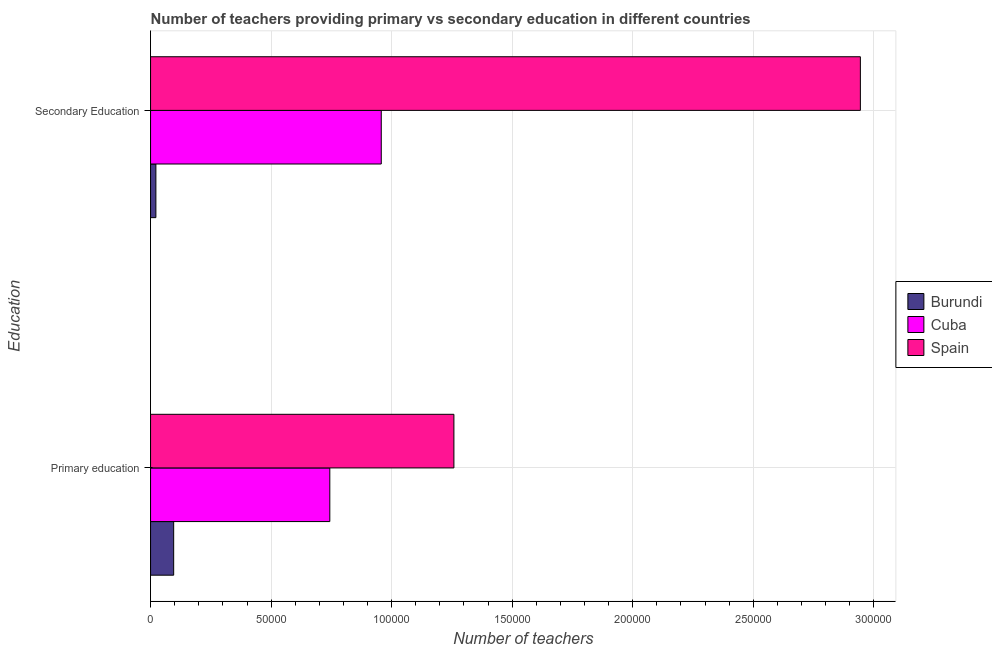How many groups of bars are there?
Provide a short and direct response. 2. Are the number of bars per tick equal to the number of legend labels?
Your answer should be compact. Yes. Are the number of bars on each tick of the Y-axis equal?
Your response must be concise. Yes. How many bars are there on the 2nd tick from the top?
Your answer should be compact. 3. What is the number of secondary teachers in Spain?
Offer a very short reply. 2.94e+05. Across all countries, what is the maximum number of primary teachers?
Your answer should be compact. 1.26e+05. Across all countries, what is the minimum number of secondary teachers?
Give a very brief answer. 2211. In which country was the number of primary teachers maximum?
Provide a short and direct response. Spain. In which country was the number of secondary teachers minimum?
Make the answer very short. Burundi. What is the total number of primary teachers in the graph?
Provide a short and direct response. 2.10e+05. What is the difference between the number of primary teachers in Cuba and that in Spain?
Provide a short and direct response. -5.15e+04. What is the difference between the number of secondary teachers in Burundi and the number of primary teachers in Spain?
Offer a very short reply. -1.24e+05. What is the average number of secondary teachers per country?
Make the answer very short. 1.31e+05. What is the difference between the number of primary teachers and number of secondary teachers in Cuba?
Offer a very short reply. -2.13e+04. In how many countries, is the number of secondary teachers greater than 270000 ?
Provide a short and direct response. 1. What is the ratio of the number of primary teachers in Cuba to that in Burundi?
Ensure brevity in your answer.  7.76. Is the number of primary teachers in Spain less than that in Burundi?
Provide a short and direct response. No. What does the 2nd bar from the top in Secondary Education represents?
Give a very brief answer. Cuba. Are the values on the major ticks of X-axis written in scientific E-notation?
Your answer should be very brief. No. Does the graph contain any zero values?
Your answer should be very brief. No. Where does the legend appear in the graph?
Make the answer very short. Center right. How many legend labels are there?
Provide a succinct answer. 3. How are the legend labels stacked?
Your response must be concise. Vertical. What is the title of the graph?
Offer a very short reply. Number of teachers providing primary vs secondary education in different countries. Does "Oman" appear as one of the legend labels in the graph?
Provide a short and direct response. No. What is the label or title of the X-axis?
Offer a terse response. Number of teachers. What is the label or title of the Y-axis?
Your answer should be compact. Education. What is the Number of teachers of Burundi in Primary education?
Offer a very short reply. 9582. What is the Number of teachers in Cuba in Primary education?
Provide a short and direct response. 7.44e+04. What is the Number of teachers of Spain in Primary education?
Offer a terse response. 1.26e+05. What is the Number of teachers in Burundi in Secondary Education?
Provide a short and direct response. 2211. What is the Number of teachers of Cuba in Secondary Education?
Offer a terse response. 9.57e+04. What is the Number of teachers in Spain in Secondary Education?
Offer a very short reply. 2.94e+05. Across all Education, what is the maximum Number of teachers in Burundi?
Keep it short and to the point. 9582. Across all Education, what is the maximum Number of teachers in Cuba?
Make the answer very short. 9.57e+04. Across all Education, what is the maximum Number of teachers of Spain?
Offer a very short reply. 2.94e+05. Across all Education, what is the minimum Number of teachers in Burundi?
Your response must be concise. 2211. Across all Education, what is the minimum Number of teachers of Cuba?
Your answer should be compact. 7.44e+04. Across all Education, what is the minimum Number of teachers in Spain?
Offer a terse response. 1.26e+05. What is the total Number of teachers of Burundi in the graph?
Your response must be concise. 1.18e+04. What is the total Number of teachers in Cuba in the graph?
Keep it short and to the point. 1.70e+05. What is the total Number of teachers of Spain in the graph?
Keep it short and to the point. 4.20e+05. What is the difference between the Number of teachers in Burundi in Primary education and that in Secondary Education?
Provide a succinct answer. 7371. What is the difference between the Number of teachers of Cuba in Primary education and that in Secondary Education?
Ensure brevity in your answer.  -2.13e+04. What is the difference between the Number of teachers of Spain in Primary education and that in Secondary Education?
Ensure brevity in your answer.  -1.69e+05. What is the difference between the Number of teachers of Burundi in Primary education and the Number of teachers of Cuba in Secondary Education?
Provide a short and direct response. -8.61e+04. What is the difference between the Number of teachers in Burundi in Primary education and the Number of teachers in Spain in Secondary Education?
Give a very brief answer. -2.85e+05. What is the difference between the Number of teachers in Cuba in Primary education and the Number of teachers in Spain in Secondary Education?
Offer a very short reply. -2.20e+05. What is the average Number of teachers in Burundi per Education?
Offer a very short reply. 5896.5. What is the average Number of teachers of Cuba per Education?
Offer a terse response. 8.50e+04. What is the average Number of teachers in Spain per Education?
Ensure brevity in your answer.  2.10e+05. What is the difference between the Number of teachers of Burundi and Number of teachers of Cuba in Primary education?
Keep it short and to the point. -6.48e+04. What is the difference between the Number of teachers in Burundi and Number of teachers in Spain in Primary education?
Keep it short and to the point. -1.16e+05. What is the difference between the Number of teachers of Cuba and Number of teachers of Spain in Primary education?
Your answer should be very brief. -5.15e+04. What is the difference between the Number of teachers in Burundi and Number of teachers in Cuba in Secondary Education?
Your answer should be very brief. -9.35e+04. What is the difference between the Number of teachers of Burundi and Number of teachers of Spain in Secondary Education?
Give a very brief answer. -2.92e+05. What is the difference between the Number of teachers in Cuba and Number of teachers in Spain in Secondary Education?
Provide a short and direct response. -1.99e+05. What is the ratio of the Number of teachers of Burundi in Primary education to that in Secondary Education?
Give a very brief answer. 4.33. What is the ratio of the Number of teachers in Cuba in Primary education to that in Secondary Education?
Offer a very short reply. 0.78. What is the ratio of the Number of teachers in Spain in Primary education to that in Secondary Education?
Ensure brevity in your answer.  0.43. What is the difference between the highest and the second highest Number of teachers of Burundi?
Your response must be concise. 7371. What is the difference between the highest and the second highest Number of teachers of Cuba?
Your answer should be very brief. 2.13e+04. What is the difference between the highest and the second highest Number of teachers in Spain?
Make the answer very short. 1.69e+05. What is the difference between the highest and the lowest Number of teachers in Burundi?
Ensure brevity in your answer.  7371. What is the difference between the highest and the lowest Number of teachers of Cuba?
Provide a short and direct response. 2.13e+04. What is the difference between the highest and the lowest Number of teachers of Spain?
Offer a very short reply. 1.69e+05. 